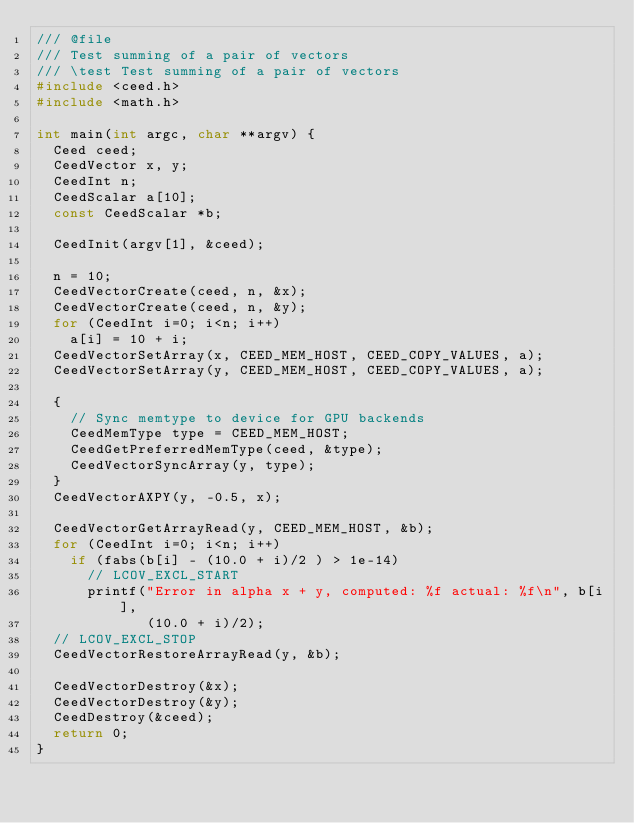Convert code to text. <code><loc_0><loc_0><loc_500><loc_500><_C_>/// @file
/// Test summing of a pair of vectors
/// \test Test summing of a pair of vectors
#include <ceed.h>
#include <math.h>

int main(int argc, char **argv) {
  Ceed ceed;
  CeedVector x, y;
  CeedInt n;
  CeedScalar a[10];
  const CeedScalar *b;

  CeedInit(argv[1], &ceed);

  n = 10;
  CeedVectorCreate(ceed, n, &x);
  CeedVectorCreate(ceed, n, &y);
  for (CeedInt i=0; i<n; i++)
    a[i] = 10 + i;
  CeedVectorSetArray(x, CEED_MEM_HOST, CEED_COPY_VALUES, a);
  CeedVectorSetArray(y, CEED_MEM_HOST, CEED_COPY_VALUES, a);

  {
    // Sync memtype to device for GPU backends
    CeedMemType type = CEED_MEM_HOST;
    CeedGetPreferredMemType(ceed, &type);
    CeedVectorSyncArray(y, type);
  }
  CeedVectorAXPY(y, -0.5, x);

  CeedVectorGetArrayRead(y, CEED_MEM_HOST, &b);
  for (CeedInt i=0; i<n; i++)
    if (fabs(b[i] - (10.0 + i)/2 ) > 1e-14)
      // LCOV_EXCL_START
      printf("Error in alpha x + y, computed: %f actual: %f\n", b[i],
             (10.0 + i)/2);
  // LCOV_EXCL_STOP
  CeedVectorRestoreArrayRead(y, &b);

  CeedVectorDestroy(&x);
  CeedVectorDestroy(&y);
  CeedDestroy(&ceed);
  return 0;
}
</code> 